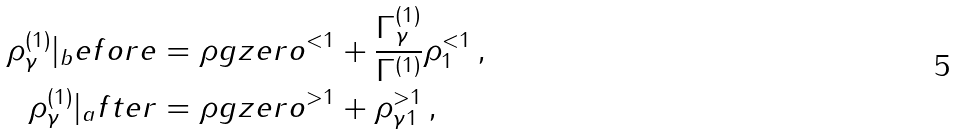Convert formula to latex. <formula><loc_0><loc_0><loc_500><loc_500>\rho _ { \gamma } ^ { ( 1 ) } | _ { b } e f o r e & = \rho g z e r o ^ { < 1 } + \frac { \Gamma _ { \gamma } ^ { ( 1 ) } } { \Gamma ^ { ( 1 ) } } \rho _ { 1 } ^ { < 1 } \, , \\ \rho _ { \gamma } ^ { ( 1 ) } | _ { a } f t e r & = \rho g z e r o ^ { > 1 } + \rho _ { \gamma 1 } ^ { > 1 } \, ,</formula> 